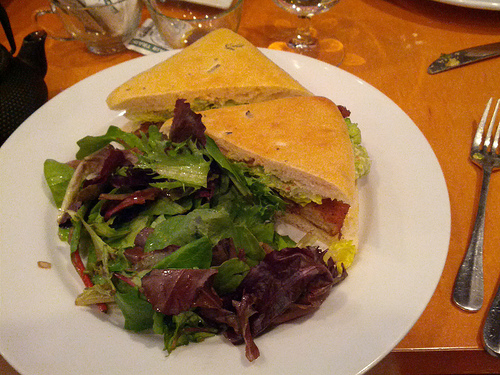Are there both a plate and a knife in the image? Yes, both a plate and a knife are present. The plate underlies the sandwich and salad, and the knife is partially obscured to the right. 